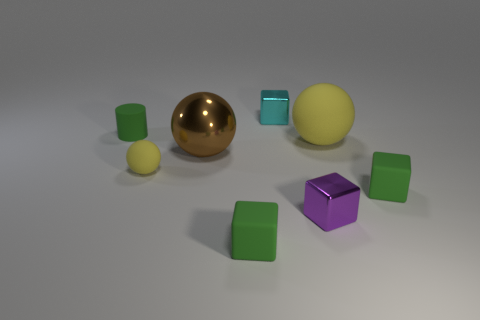Add 2 purple blocks. How many objects exist? 10 Subtract 0 blue cylinders. How many objects are left? 8 Subtract all spheres. How many objects are left? 5 Subtract 2 spheres. How many spheres are left? 1 Subtract all red blocks. Subtract all purple balls. How many blocks are left? 4 Subtract all cyan spheres. How many blue cylinders are left? 0 Subtract all purple rubber cubes. Subtract all tiny green matte cylinders. How many objects are left? 7 Add 3 green rubber objects. How many green rubber objects are left? 6 Add 1 green cylinders. How many green cylinders exist? 2 Subtract all purple blocks. How many blocks are left? 3 